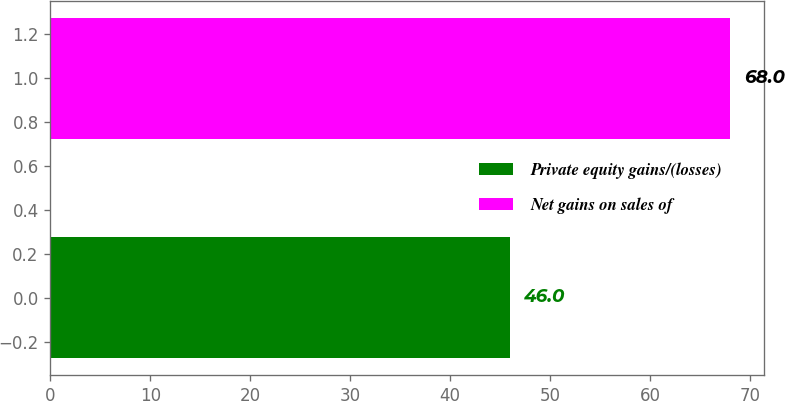<chart> <loc_0><loc_0><loc_500><loc_500><bar_chart><fcel>Private equity gains/(losses)<fcel>Net gains on sales of<nl><fcel>46<fcel>68<nl></chart> 